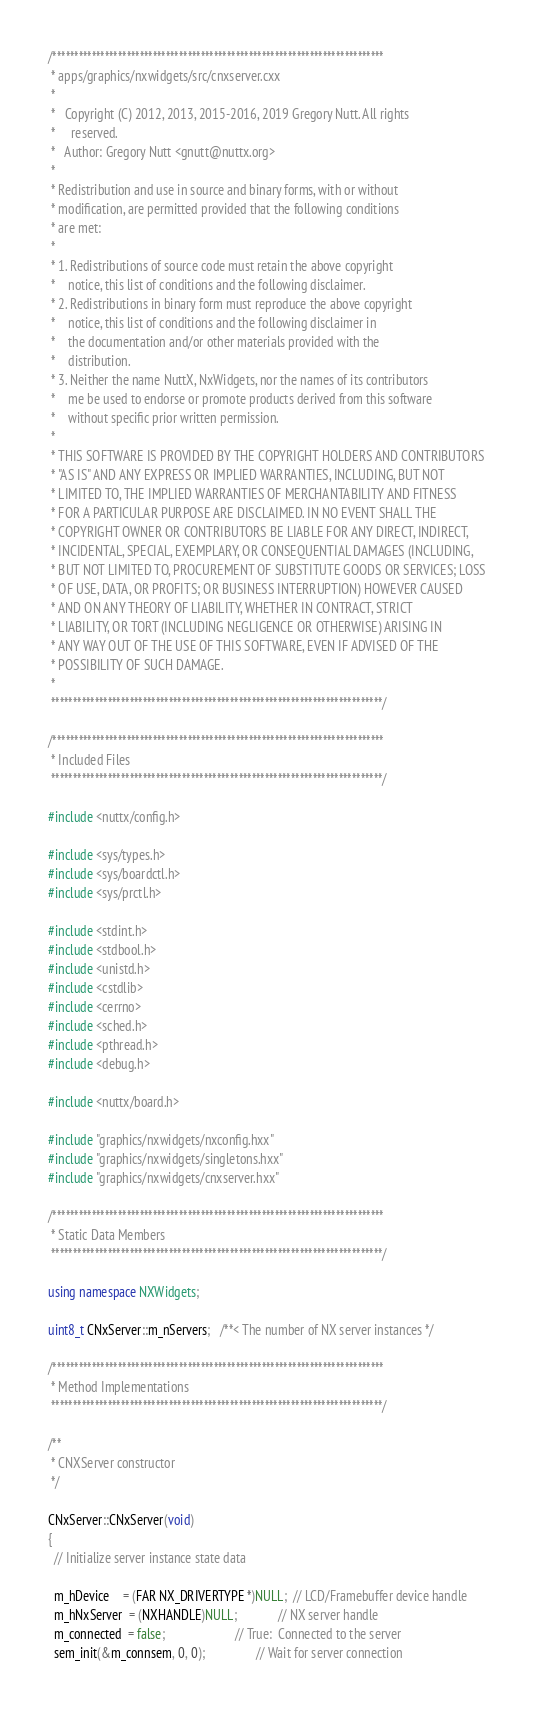<code> <loc_0><loc_0><loc_500><loc_500><_C++_>/****************************************************************************
 * apps/graphics/nxwidgets/src/cnxserver.cxx
 *
 *   Copyright (C) 2012, 2013, 2015-2016, 2019 Gregory Nutt. All rights
 *     reserved.
 *   Author: Gregory Nutt <gnutt@nuttx.org>
 *
 * Redistribution and use in source and binary forms, with or without
 * modification, are permitted provided that the following conditions
 * are met:
 *
 * 1. Redistributions of source code must retain the above copyright
 *    notice, this list of conditions and the following disclaimer.
 * 2. Redistributions in binary form must reproduce the above copyright
 *    notice, this list of conditions and the following disclaimer in
 *    the documentation and/or other materials provided with the
 *    distribution.
 * 3. Neither the name NuttX, NxWidgets, nor the names of its contributors
 *    me be used to endorse or promote products derived from this software
 *    without specific prior written permission.
 *
 * THIS SOFTWARE IS PROVIDED BY THE COPYRIGHT HOLDERS AND CONTRIBUTORS
 * "AS IS" AND ANY EXPRESS OR IMPLIED WARRANTIES, INCLUDING, BUT NOT
 * LIMITED TO, THE IMPLIED WARRANTIES OF MERCHANTABILITY AND FITNESS
 * FOR A PARTICULAR PURPOSE ARE DISCLAIMED. IN NO EVENT SHALL THE
 * COPYRIGHT OWNER OR CONTRIBUTORS BE LIABLE FOR ANY DIRECT, INDIRECT,
 * INCIDENTAL, SPECIAL, EXEMPLARY, OR CONSEQUENTIAL DAMAGES (INCLUDING,
 * BUT NOT LIMITED TO, PROCUREMENT OF SUBSTITUTE GOODS OR SERVICES; LOSS
 * OF USE, DATA, OR PROFITS; OR BUSINESS INTERRUPTION) HOWEVER CAUSED
 * AND ON ANY THEORY OF LIABILITY, WHETHER IN CONTRACT, STRICT
 * LIABILITY, OR TORT (INCLUDING NEGLIGENCE OR OTHERWISE) ARISING IN
 * ANY WAY OUT OF THE USE OF THIS SOFTWARE, EVEN IF ADVISED OF THE
 * POSSIBILITY OF SUCH DAMAGE.
 *
 ****************************************************************************/

/****************************************************************************
 * Included Files
 ****************************************************************************/

#include <nuttx/config.h>

#include <sys/types.h>
#include <sys/boardctl.h>
#include <sys/prctl.h>

#include <stdint.h>
#include <stdbool.h>
#include <unistd.h>
#include <cstdlib>
#include <cerrno>
#include <sched.h>
#include <pthread.h>
#include <debug.h>

#include <nuttx/board.h>

#include "graphics/nxwidgets/nxconfig.hxx"
#include "graphics/nxwidgets/singletons.hxx"
#include "graphics/nxwidgets/cnxserver.hxx"

/****************************************************************************
 * Static Data Members
 ****************************************************************************/

using namespace NXWidgets;

uint8_t CNxServer::m_nServers;   /**< The number of NX server instances */

/****************************************************************************
 * Method Implementations
 ****************************************************************************/

/**
 * CNXServer constructor
 */

CNxServer::CNxServer(void)
{
  // Initialize server instance state data

  m_hDevice    = (FAR NX_DRIVERTYPE *)NULL;  // LCD/Framebuffer device handle
  m_hNxServer  = (NXHANDLE)NULL;             // NX server handle
  m_connected  = false;                      // True:  Connected to the server
  sem_init(&m_connsem, 0, 0);                // Wait for server connection
</code> 